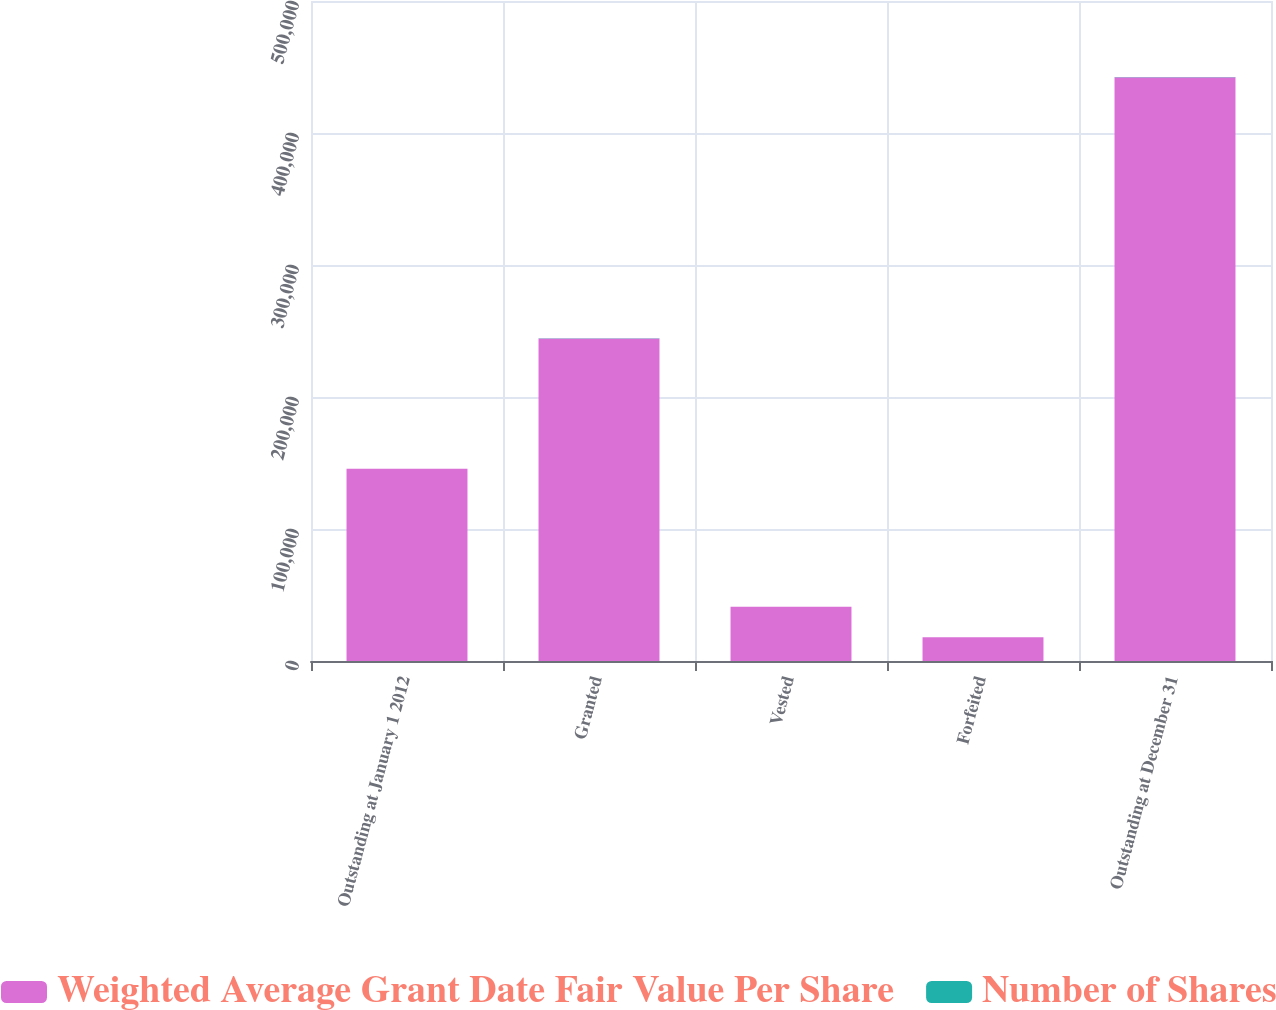Convert chart. <chart><loc_0><loc_0><loc_500><loc_500><stacked_bar_chart><ecel><fcel>Outstanding at January 1 2012<fcel>Granted<fcel>Vested<fcel>Forfeited<fcel>Outstanding at December 31<nl><fcel>Weighted Average Grant Date Fair Value Per Share<fcel>145634<fcel>244397<fcel>41120<fcel>17898<fcel>442310<nl><fcel>Number of Shares<fcel>33.32<fcel>47.1<fcel>34.51<fcel>43.27<fcel>56.84<nl></chart> 